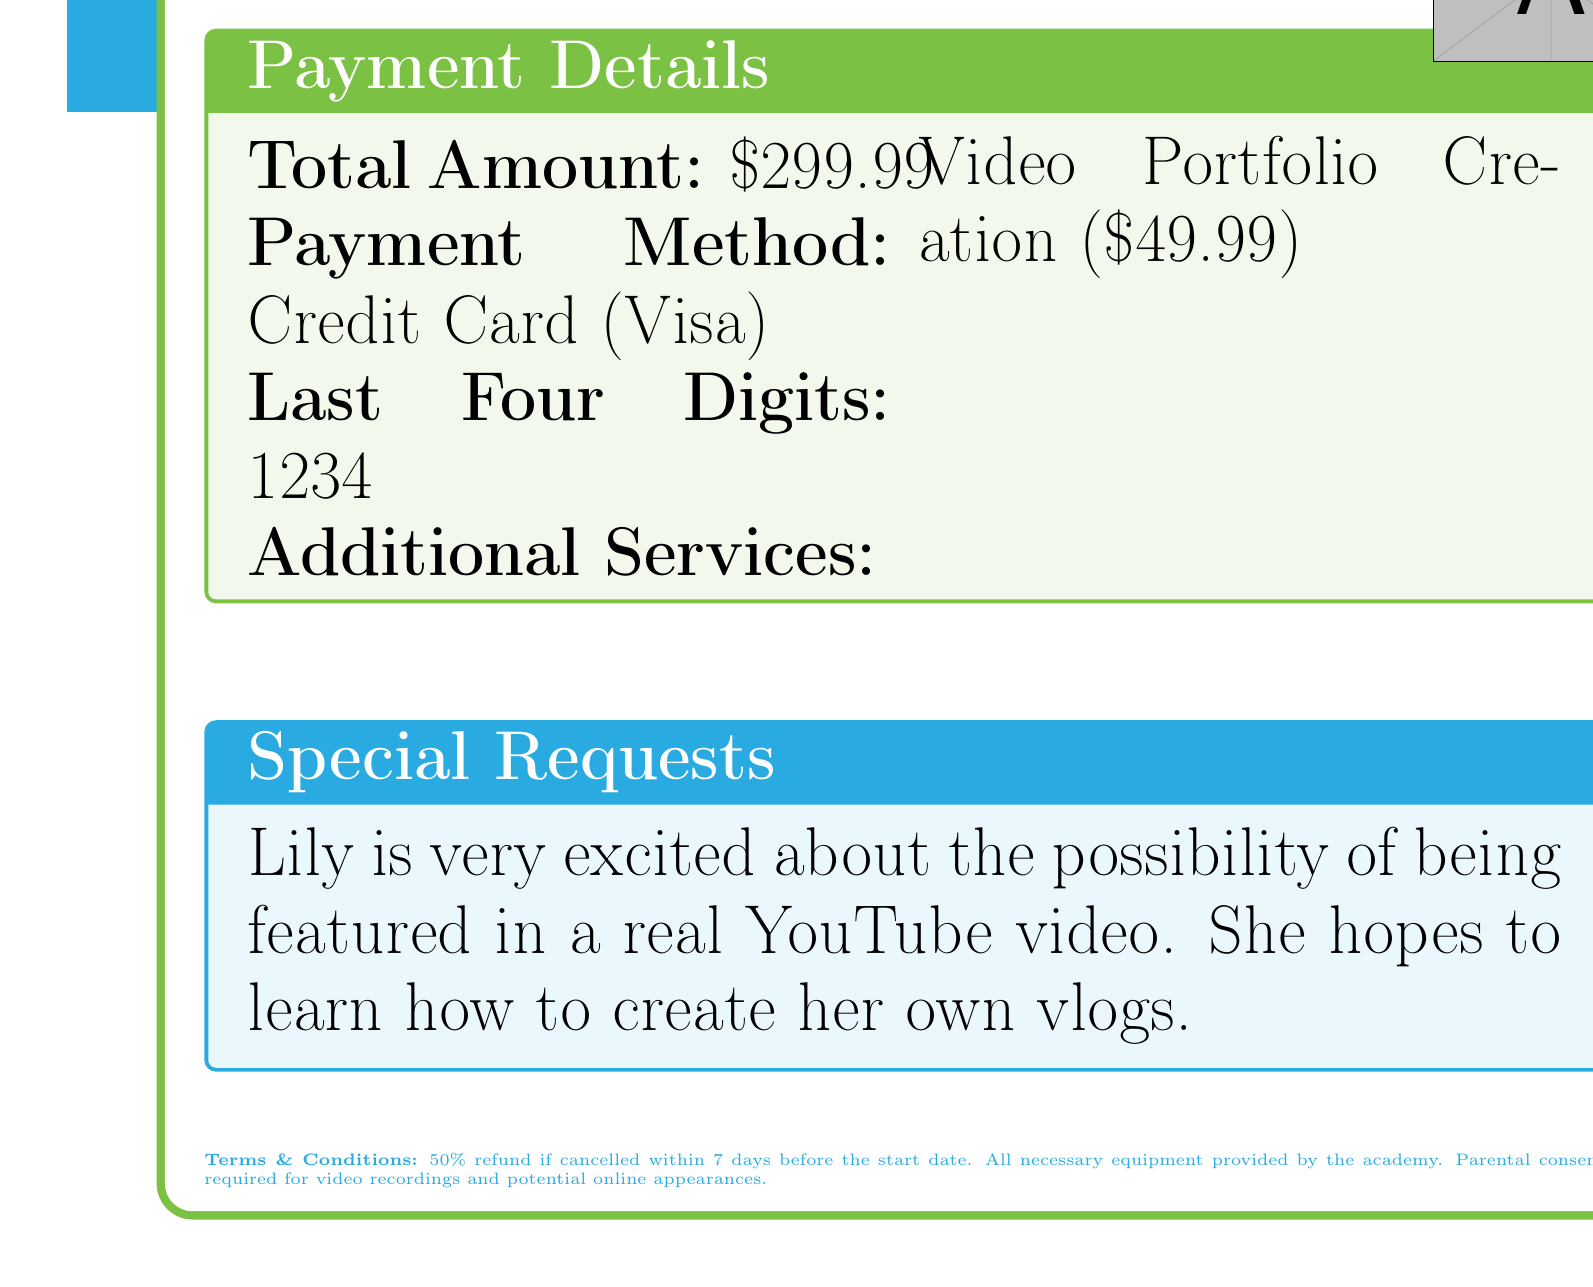What is the transaction ID? The transaction ID is mentioned in the transaction details section as an identifier for the transaction.
Answer: VKA-2023-0512 Who is the instructor for the class? The instructor's name is provided in the class details section along with other class information.
Answer: Emma Rodriguez What is the total amount for the class? The total amount is specified in the payment info section as the overall cost for the subscription.
Answer: 299.99 When does the class start? The start date is clearly outlined in the class details section as part of the schedule for the class.
Answer: June 3, 2023 What special request did Lily have? The document mentions specific special requests made by Lily related to her excitement for the class.
Answer: Lily is very excited about the possibility of being featured in a real YouTube video How long is the duration of the class? The duration is specified in the class details section, indicating how many weeks the class will run.
Answer: 8 weeks What is the payment method used? The payment method is noted in the payment information section, detailing how the payment was made.
Answer: Credit Card What is one of the course highlights? The course highlights list includes multiple activities that will be taught during the class, and any one of them can be referenced.
Answer: Introduction to acting for the camera 